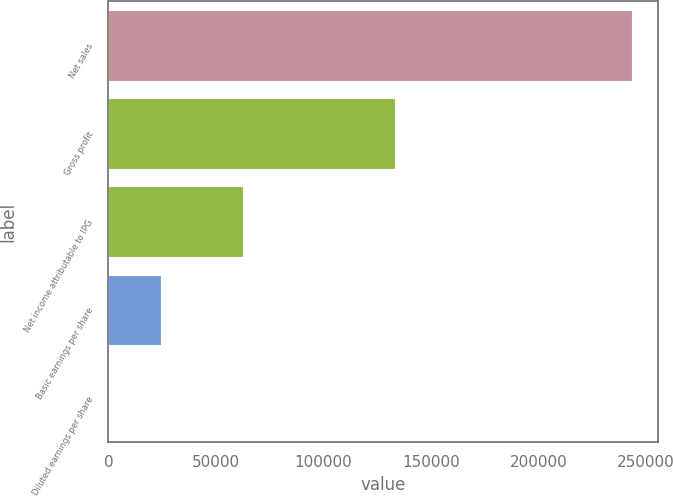Convert chart to OTSL. <chart><loc_0><loc_0><loc_500><loc_500><bar_chart><fcel>Net sales<fcel>Gross profit<fcel>Net income attributable to IPG<fcel>Basic earnings per share<fcel>Diluted earnings per share<nl><fcel>243541<fcel>133304<fcel>62792<fcel>24355.2<fcel>1.18<nl></chart> 